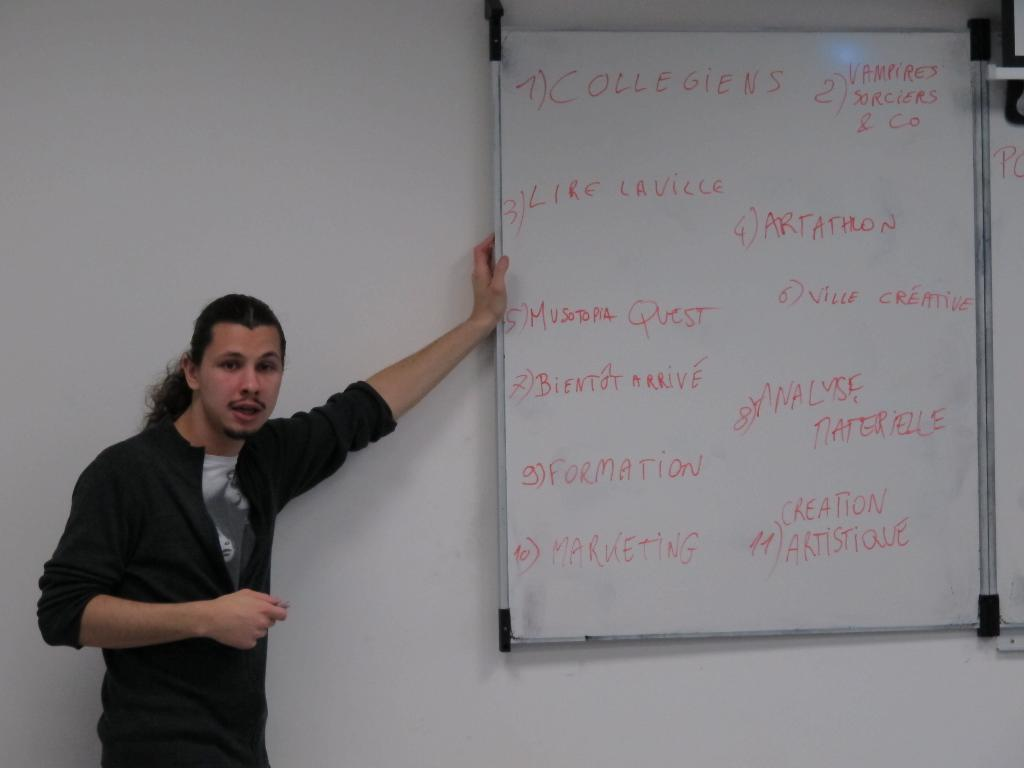<image>
Summarize the visual content of the image. A man leans against a whiteboard, which lists several things in red ink, the first of which is Collegiens. 